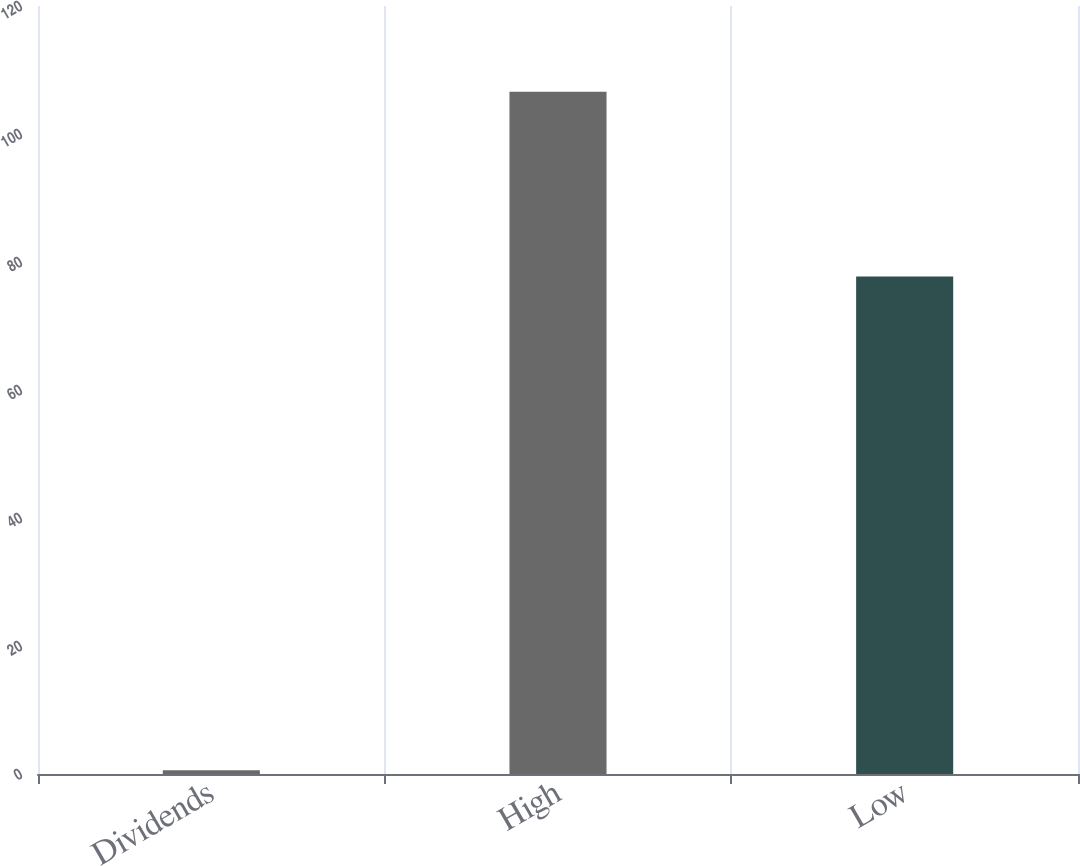Convert chart. <chart><loc_0><loc_0><loc_500><loc_500><bar_chart><fcel>Dividends<fcel>High<fcel>Low<nl><fcel>0.6<fcel>106.6<fcel>77.73<nl></chart> 